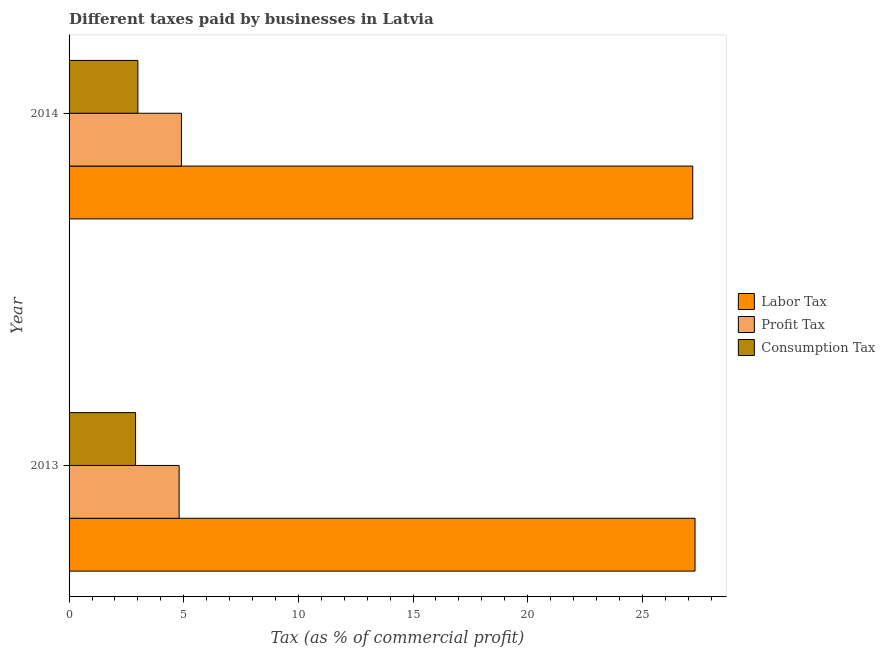In how many cases, is the number of bars for a given year not equal to the number of legend labels?
Provide a succinct answer. 0. What is the percentage of labor tax in 2014?
Offer a terse response. 27.2. Across all years, what is the maximum percentage of profit tax?
Give a very brief answer. 4.9. Across all years, what is the minimum percentage of labor tax?
Provide a short and direct response. 27.2. In which year was the percentage of consumption tax maximum?
Provide a succinct answer. 2014. What is the difference between the percentage of consumption tax in 2013 and that in 2014?
Your response must be concise. -0.1. What is the difference between the percentage of consumption tax in 2013 and the percentage of profit tax in 2014?
Make the answer very short. -2. What is the average percentage of profit tax per year?
Provide a succinct answer. 4.85. In the year 2014, what is the difference between the percentage of profit tax and percentage of consumption tax?
Your answer should be very brief. 1.9. In how many years, is the percentage of profit tax greater than 8 %?
Ensure brevity in your answer.  0. Is the percentage of labor tax in 2013 less than that in 2014?
Provide a short and direct response. No. Is the difference between the percentage of consumption tax in 2013 and 2014 greater than the difference between the percentage of labor tax in 2013 and 2014?
Your answer should be very brief. No. In how many years, is the percentage of consumption tax greater than the average percentage of consumption tax taken over all years?
Offer a very short reply. 1. What does the 3rd bar from the top in 2013 represents?
Make the answer very short. Labor Tax. What does the 1st bar from the bottom in 2014 represents?
Your answer should be very brief. Labor Tax. Are the values on the major ticks of X-axis written in scientific E-notation?
Offer a very short reply. No. Does the graph contain any zero values?
Provide a succinct answer. No. Does the graph contain grids?
Your response must be concise. No. Where does the legend appear in the graph?
Offer a terse response. Center right. How many legend labels are there?
Provide a succinct answer. 3. What is the title of the graph?
Keep it short and to the point. Different taxes paid by businesses in Latvia. Does "Transport services" appear as one of the legend labels in the graph?
Give a very brief answer. No. What is the label or title of the X-axis?
Keep it short and to the point. Tax (as % of commercial profit). What is the label or title of the Y-axis?
Keep it short and to the point. Year. What is the Tax (as % of commercial profit) of Labor Tax in 2013?
Keep it short and to the point. 27.3. What is the Tax (as % of commercial profit) in Consumption Tax in 2013?
Offer a terse response. 2.9. What is the Tax (as % of commercial profit) of Labor Tax in 2014?
Your response must be concise. 27.2. What is the Tax (as % of commercial profit) of Consumption Tax in 2014?
Offer a terse response. 3. Across all years, what is the maximum Tax (as % of commercial profit) in Labor Tax?
Your answer should be very brief. 27.3. Across all years, what is the maximum Tax (as % of commercial profit) in Profit Tax?
Your response must be concise. 4.9. Across all years, what is the maximum Tax (as % of commercial profit) of Consumption Tax?
Your answer should be very brief. 3. Across all years, what is the minimum Tax (as % of commercial profit) of Labor Tax?
Your answer should be very brief. 27.2. What is the total Tax (as % of commercial profit) of Labor Tax in the graph?
Your answer should be compact. 54.5. What is the total Tax (as % of commercial profit) of Profit Tax in the graph?
Offer a very short reply. 9.7. What is the total Tax (as % of commercial profit) of Consumption Tax in the graph?
Your answer should be very brief. 5.9. What is the difference between the Tax (as % of commercial profit) in Profit Tax in 2013 and that in 2014?
Ensure brevity in your answer.  -0.1. What is the difference between the Tax (as % of commercial profit) in Labor Tax in 2013 and the Tax (as % of commercial profit) in Profit Tax in 2014?
Give a very brief answer. 22.4. What is the difference between the Tax (as % of commercial profit) in Labor Tax in 2013 and the Tax (as % of commercial profit) in Consumption Tax in 2014?
Your answer should be compact. 24.3. What is the average Tax (as % of commercial profit) of Labor Tax per year?
Your answer should be very brief. 27.25. What is the average Tax (as % of commercial profit) of Profit Tax per year?
Make the answer very short. 4.85. What is the average Tax (as % of commercial profit) of Consumption Tax per year?
Provide a succinct answer. 2.95. In the year 2013, what is the difference between the Tax (as % of commercial profit) of Labor Tax and Tax (as % of commercial profit) of Consumption Tax?
Keep it short and to the point. 24.4. In the year 2013, what is the difference between the Tax (as % of commercial profit) in Profit Tax and Tax (as % of commercial profit) in Consumption Tax?
Keep it short and to the point. 1.9. In the year 2014, what is the difference between the Tax (as % of commercial profit) in Labor Tax and Tax (as % of commercial profit) in Profit Tax?
Give a very brief answer. 22.3. In the year 2014, what is the difference between the Tax (as % of commercial profit) in Labor Tax and Tax (as % of commercial profit) in Consumption Tax?
Provide a short and direct response. 24.2. In the year 2014, what is the difference between the Tax (as % of commercial profit) in Profit Tax and Tax (as % of commercial profit) in Consumption Tax?
Your response must be concise. 1.9. What is the ratio of the Tax (as % of commercial profit) of Profit Tax in 2013 to that in 2014?
Your answer should be compact. 0.98. What is the ratio of the Tax (as % of commercial profit) in Consumption Tax in 2013 to that in 2014?
Your response must be concise. 0.97. What is the difference between the highest and the second highest Tax (as % of commercial profit) in Profit Tax?
Provide a short and direct response. 0.1. What is the difference between the highest and the lowest Tax (as % of commercial profit) in Profit Tax?
Your answer should be compact. 0.1. What is the difference between the highest and the lowest Tax (as % of commercial profit) of Consumption Tax?
Provide a succinct answer. 0.1. 